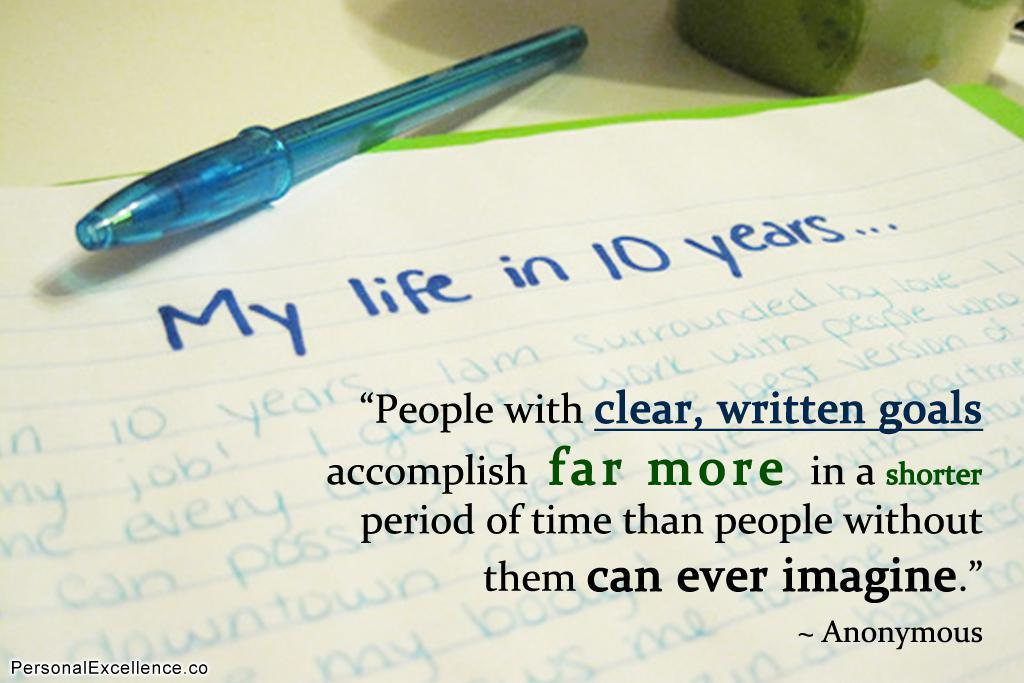What is written on the paper in the image? The facts do not provide information about the presence of a paper with text, but the specific content of the text is not mentioned. Therefore, we cannot answer this question definitively. What can be seen in the background of the image? There is a pen in the background of the image. What is located on the table in the image? There is an object on the table in the image. How does the paper sense the presence of the vase in the image? There is no vase present in the image, so the paper cannot sense its presence. Is the person in the image sleeping? The facts do not mention the presence of a person in the image, so we cannot determine if they are sleeping or not. 